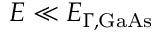<formula> <loc_0><loc_0><loc_500><loc_500>E \ll E _ { \Gamma , G a A s }</formula> 